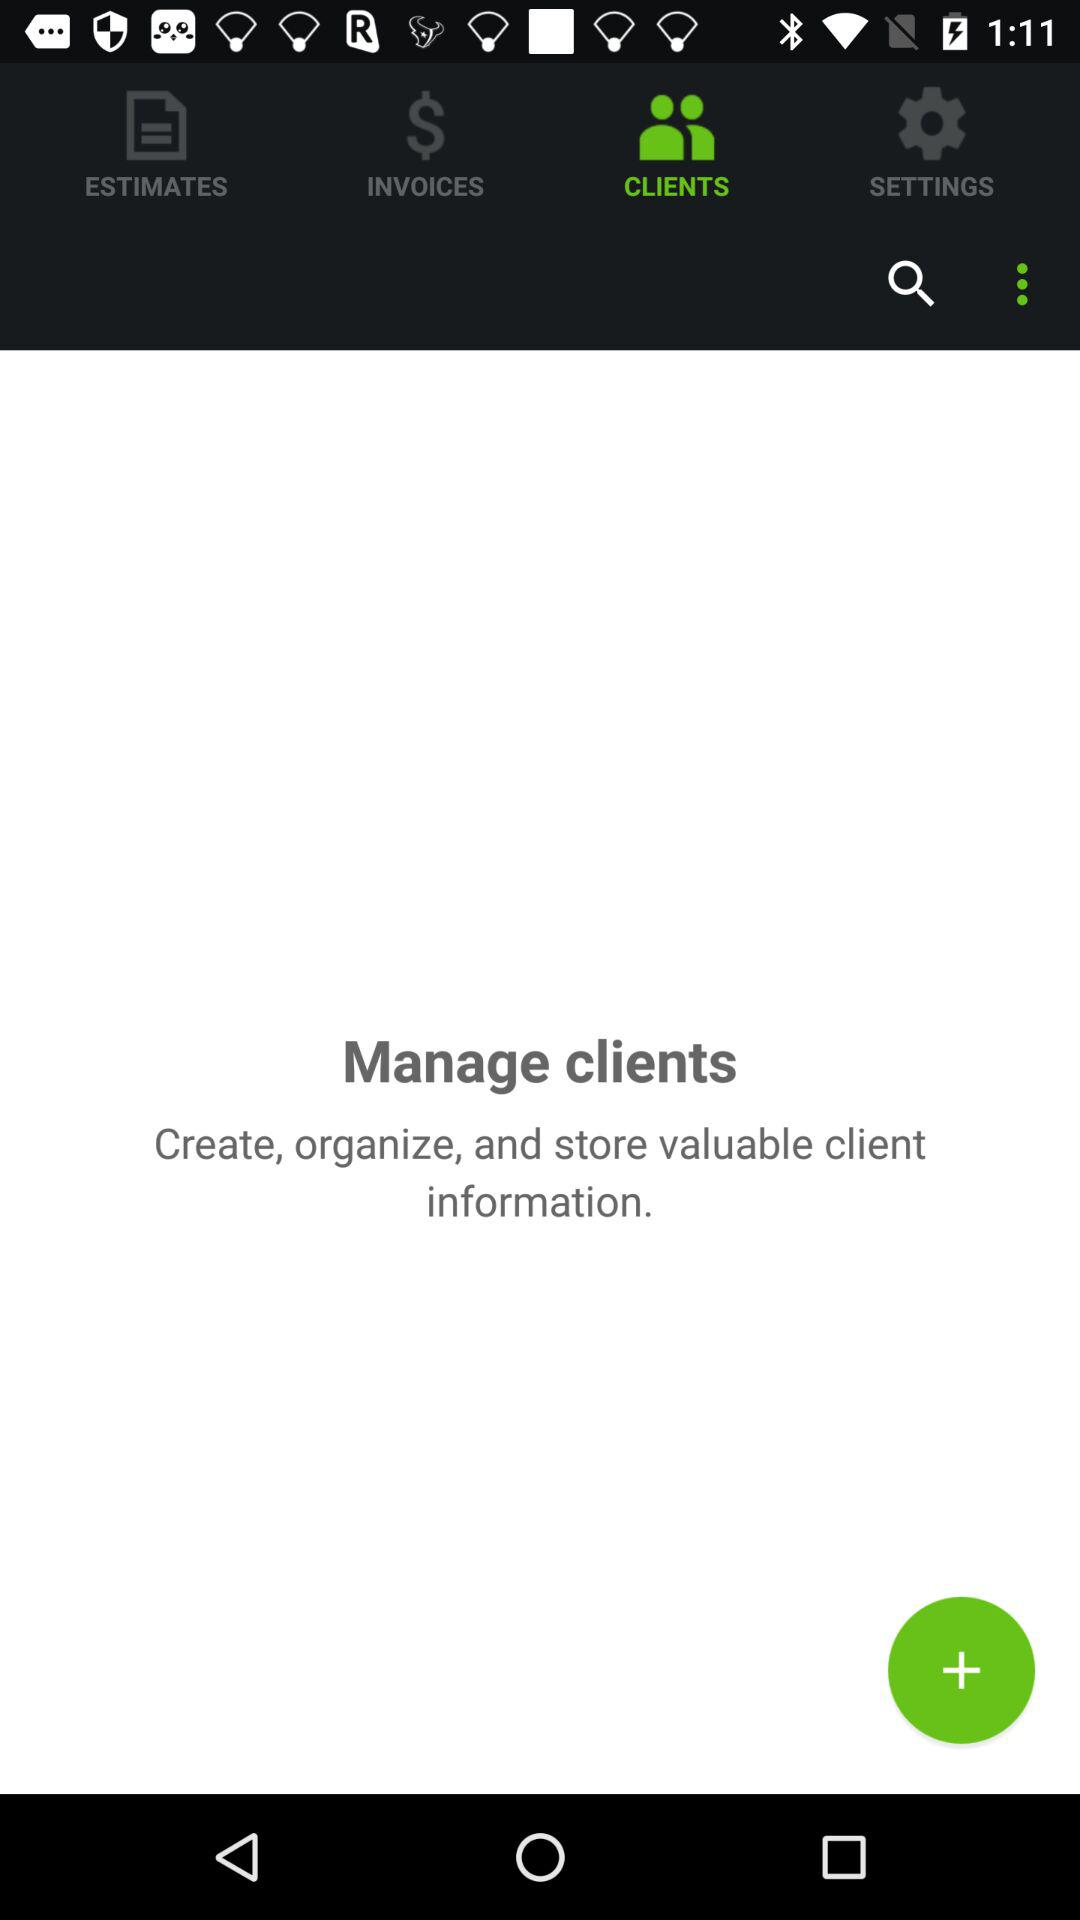Which invoices have been paid?
When the provided information is insufficient, respond with <no answer>. <no answer> 